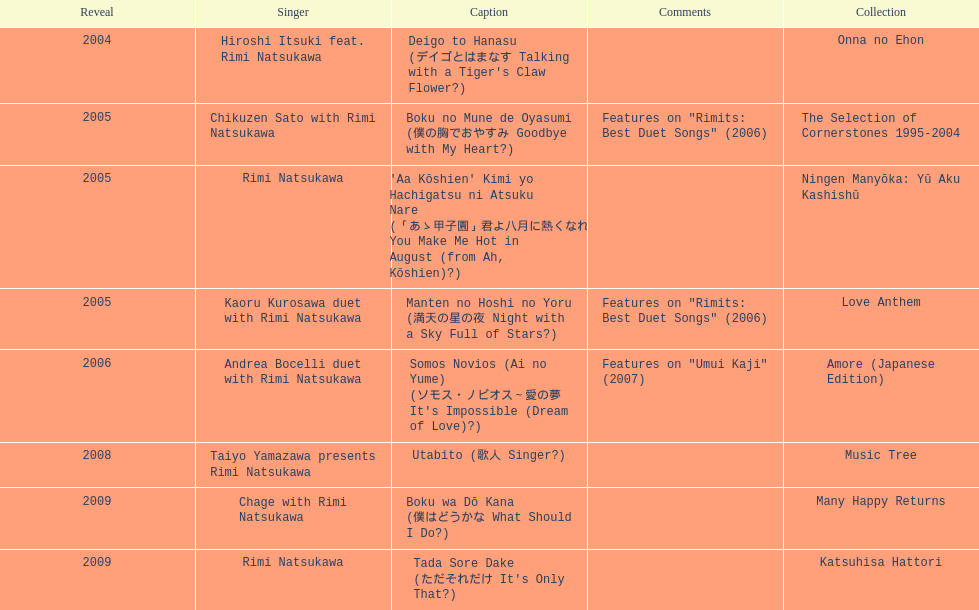What was the album released immediately before the one that had boku wa do kana on it? Music Tree. 